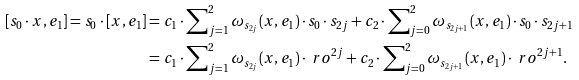<formula> <loc_0><loc_0><loc_500><loc_500>[ s _ { 0 } \cdot x , e _ { 1 } ] = s _ { 0 } \cdot [ x , e _ { 1 } ] & = c _ { 1 } \cdot \sum \nolimits _ { j = 1 } ^ { 2 } \omega _ { s _ { 2 j } } ( x , e _ { 1 } ) \cdot s _ { 0 } \cdot s _ { 2 j } + c _ { 2 } \cdot \sum \nolimits _ { j = 0 } ^ { 2 } \omega _ { s _ { 2 j + 1 } } ( x , e _ { 1 } ) \cdot s _ { 0 } \cdot s _ { 2 j + 1 } \\ & = c _ { 1 } \cdot \sum \nolimits _ { j = 1 } ^ { 2 } \omega _ { s _ { 2 j } } ( x , e _ { 1 } ) \cdot \ r o ^ { 2 j } + c _ { 2 } \cdot \sum \nolimits _ { j = 0 } ^ { 2 } \omega _ { s _ { 2 j + 1 } } ( x , e _ { 1 } ) \cdot \ r o ^ { 2 j + 1 } .</formula> 